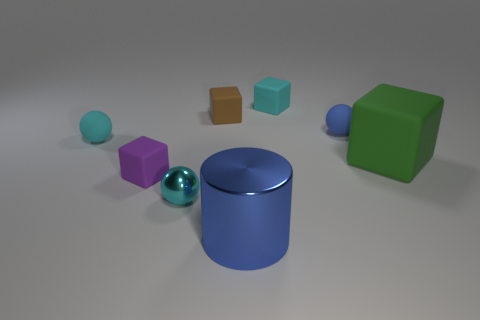What materials do the objects in the image seem to be made of, and what does that suggest about their setting? The objects in the image appear to be made of varying materials, such as rubber and plastic, with different textures like matte and shiny finishes. These items, in combination with the clean, unadorned background, suggest that the setting could be a controlled environment such as a photography studio or a 3D rendering designed to showcase the objects without external distractions. 